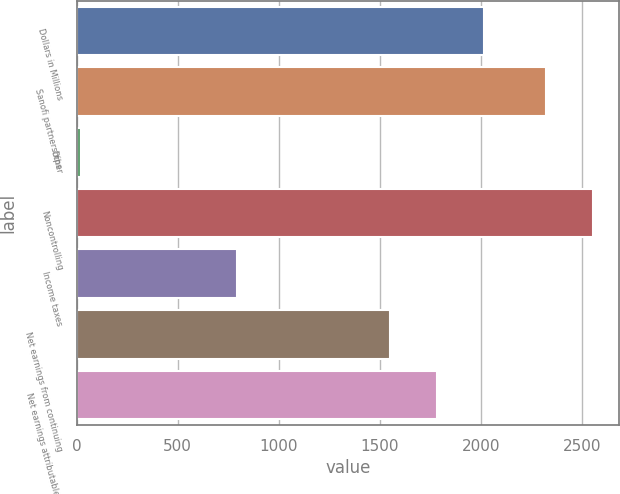Convert chart. <chart><loc_0><loc_0><loc_500><loc_500><bar_chart><fcel>Dollars in Millions<fcel>Sanofi partnerships<fcel>Other<fcel>Noncontrolling<fcel>Income taxes<fcel>Net earnings from continuing<fcel>Net earnings attributable to<nl><fcel>2015.6<fcel>2323<fcel>20<fcel>2555.3<fcel>792<fcel>1551<fcel>1783.3<nl></chart> 